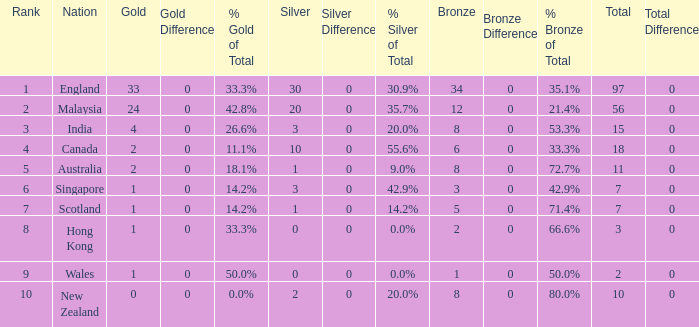What is the total number of bronze a team with more than 0 silver, a total of 7 medals, and less than 1 gold medal has? 0.0. 